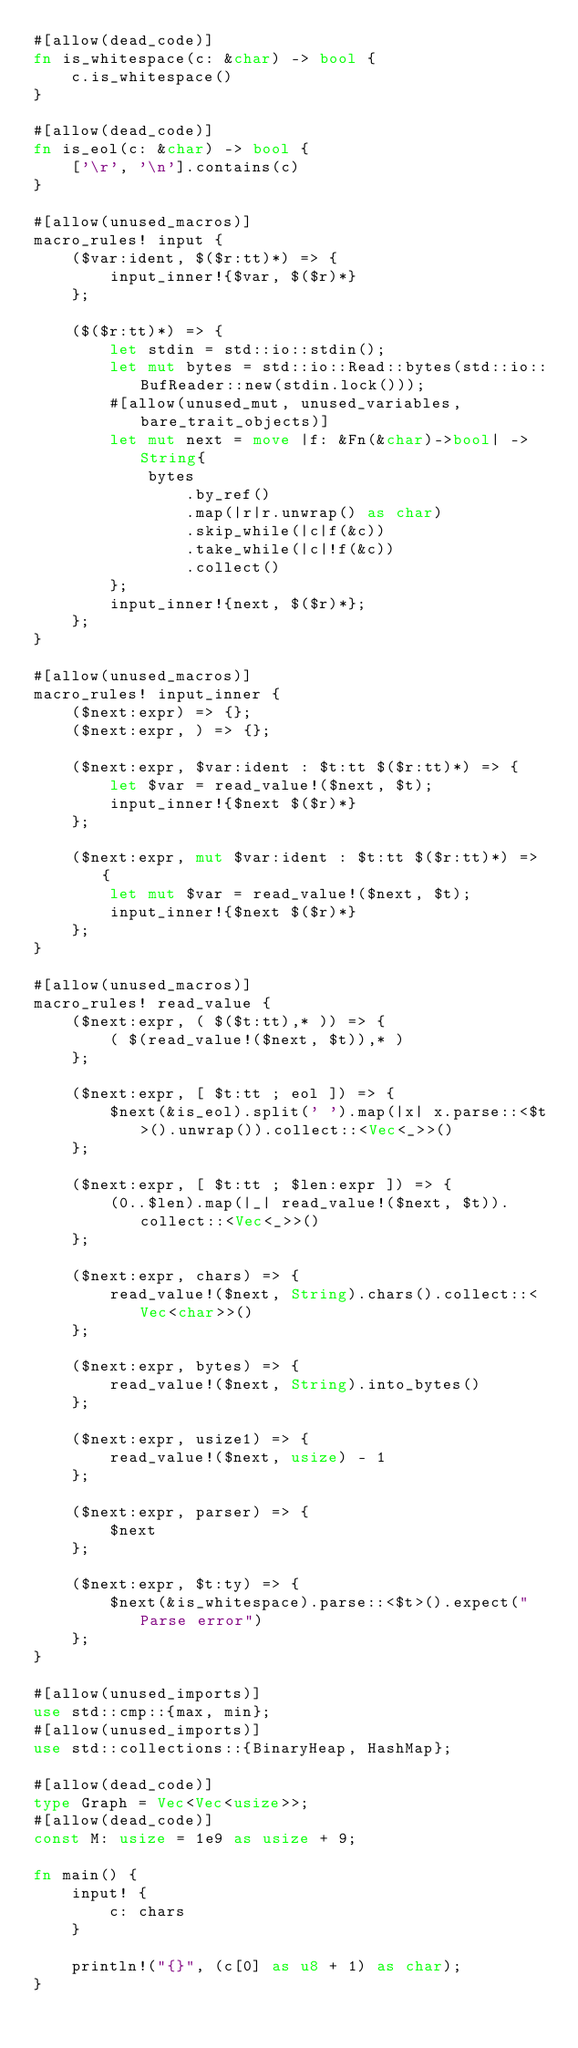<code> <loc_0><loc_0><loc_500><loc_500><_Rust_>#[allow(dead_code)]
fn is_whitespace(c: &char) -> bool {
    c.is_whitespace()
}

#[allow(dead_code)]
fn is_eol(c: &char) -> bool {
    ['\r', '\n'].contains(c)
}

#[allow(unused_macros)]
macro_rules! input {
    ($var:ident, $($r:tt)*) => {
        input_inner!{$var, $($r)*}
    };

    ($($r:tt)*) => {
        let stdin = std::io::stdin();
        let mut bytes = std::io::Read::bytes(std::io::BufReader::new(stdin.lock()));
        #[allow(unused_mut, unused_variables, bare_trait_objects)]
        let mut next = move |f: &Fn(&char)->bool| -> String{
            bytes
                .by_ref()
                .map(|r|r.unwrap() as char)
                .skip_while(|c|f(&c))
                .take_while(|c|!f(&c))
                .collect()
        };
        input_inner!{next, $($r)*};
    };
}

#[allow(unused_macros)]
macro_rules! input_inner {
    ($next:expr) => {};
    ($next:expr, ) => {};

    ($next:expr, $var:ident : $t:tt $($r:tt)*) => {
        let $var = read_value!($next, $t);
        input_inner!{$next $($r)*}
    };

    ($next:expr, mut $var:ident : $t:tt $($r:tt)*) => {
        let mut $var = read_value!($next, $t);
        input_inner!{$next $($r)*}
    };
}

#[allow(unused_macros)]
macro_rules! read_value {
    ($next:expr, ( $($t:tt),* )) => {
        ( $(read_value!($next, $t)),* )
    };

    ($next:expr, [ $t:tt ; eol ]) => {
        $next(&is_eol).split(' ').map(|x| x.parse::<$t>().unwrap()).collect::<Vec<_>>()
    };

    ($next:expr, [ $t:tt ; $len:expr ]) => {
        (0..$len).map(|_| read_value!($next, $t)).collect::<Vec<_>>()
    };

    ($next:expr, chars) => {
        read_value!($next, String).chars().collect::<Vec<char>>()
    };

    ($next:expr, bytes) => {
        read_value!($next, String).into_bytes()
    };

    ($next:expr, usize1) => {
        read_value!($next, usize) - 1
    };

    ($next:expr, parser) => {
        $next
    };

    ($next:expr, $t:ty) => {
        $next(&is_whitespace).parse::<$t>().expect("Parse error")
    };
}

#[allow(unused_imports)]
use std::cmp::{max, min};
#[allow(unused_imports)]
use std::collections::{BinaryHeap, HashMap};

#[allow(dead_code)]
type Graph = Vec<Vec<usize>>;
#[allow(dead_code)]
const M: usize = 1e9 as usize + 9;

fn main() {
    input! {
        c: chars
    }

    println!("{}", (c[0] as u8 + 1) as char);
}
</code> 